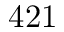Convert formula to latex. <formula><loc_0><loc_0><loc_500><loc_500>4 2 1</formula> 